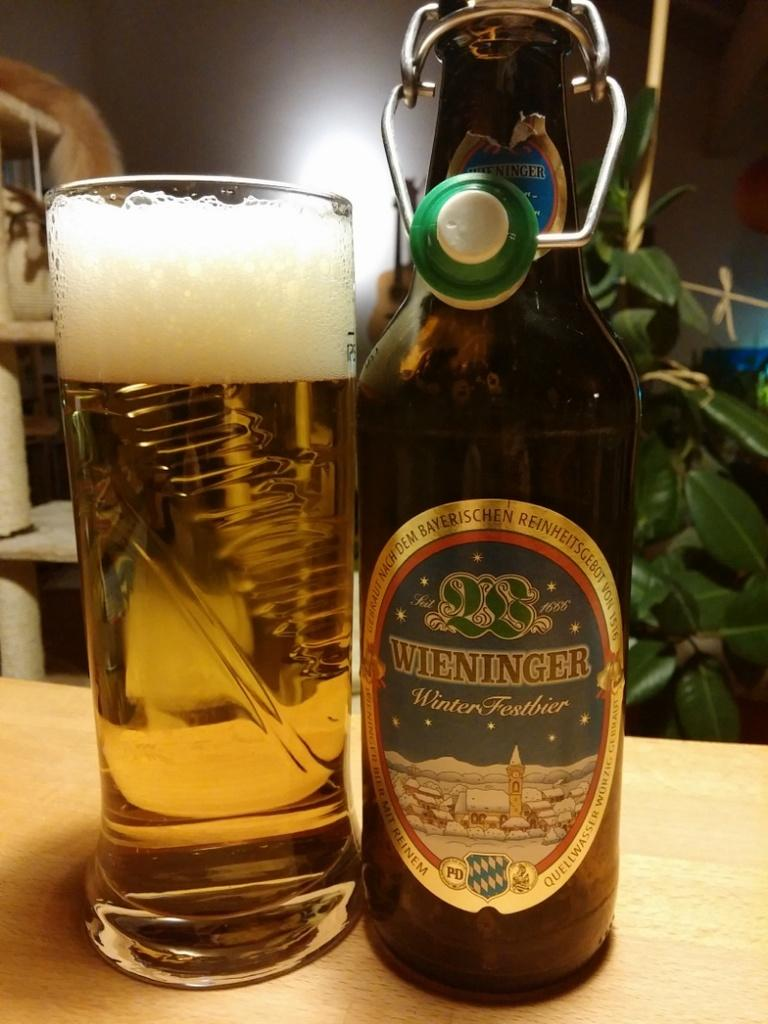<image>
Give a short and clear explanation of the subsequent image. Brown Wieninger beer bottle next to a tall cup of beer. 